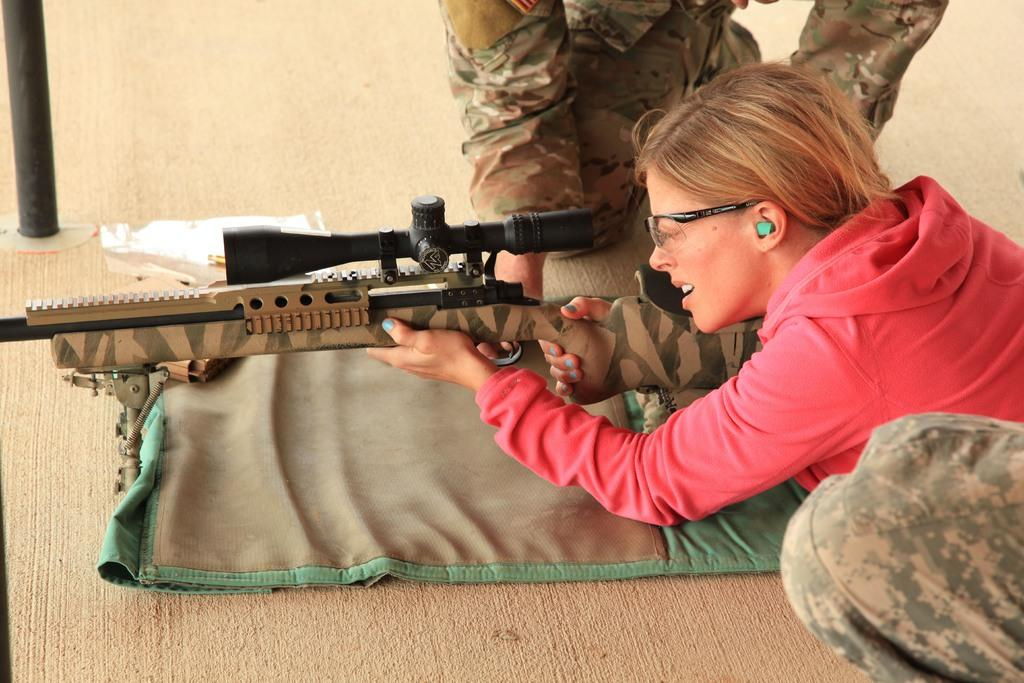Who is the main subject in the image? There is a woman in the image. What is the woman holding in the image? The woman is holding a gun. How many other people are present in the image? There are two other people in the image. What is at the bottom of the image? There is a carpet at the bottom of the image. What type of respect can be seen being given to the parent in the image? There is no parent or indication of respect in the image; it features a woman holding a gun and two other people. 